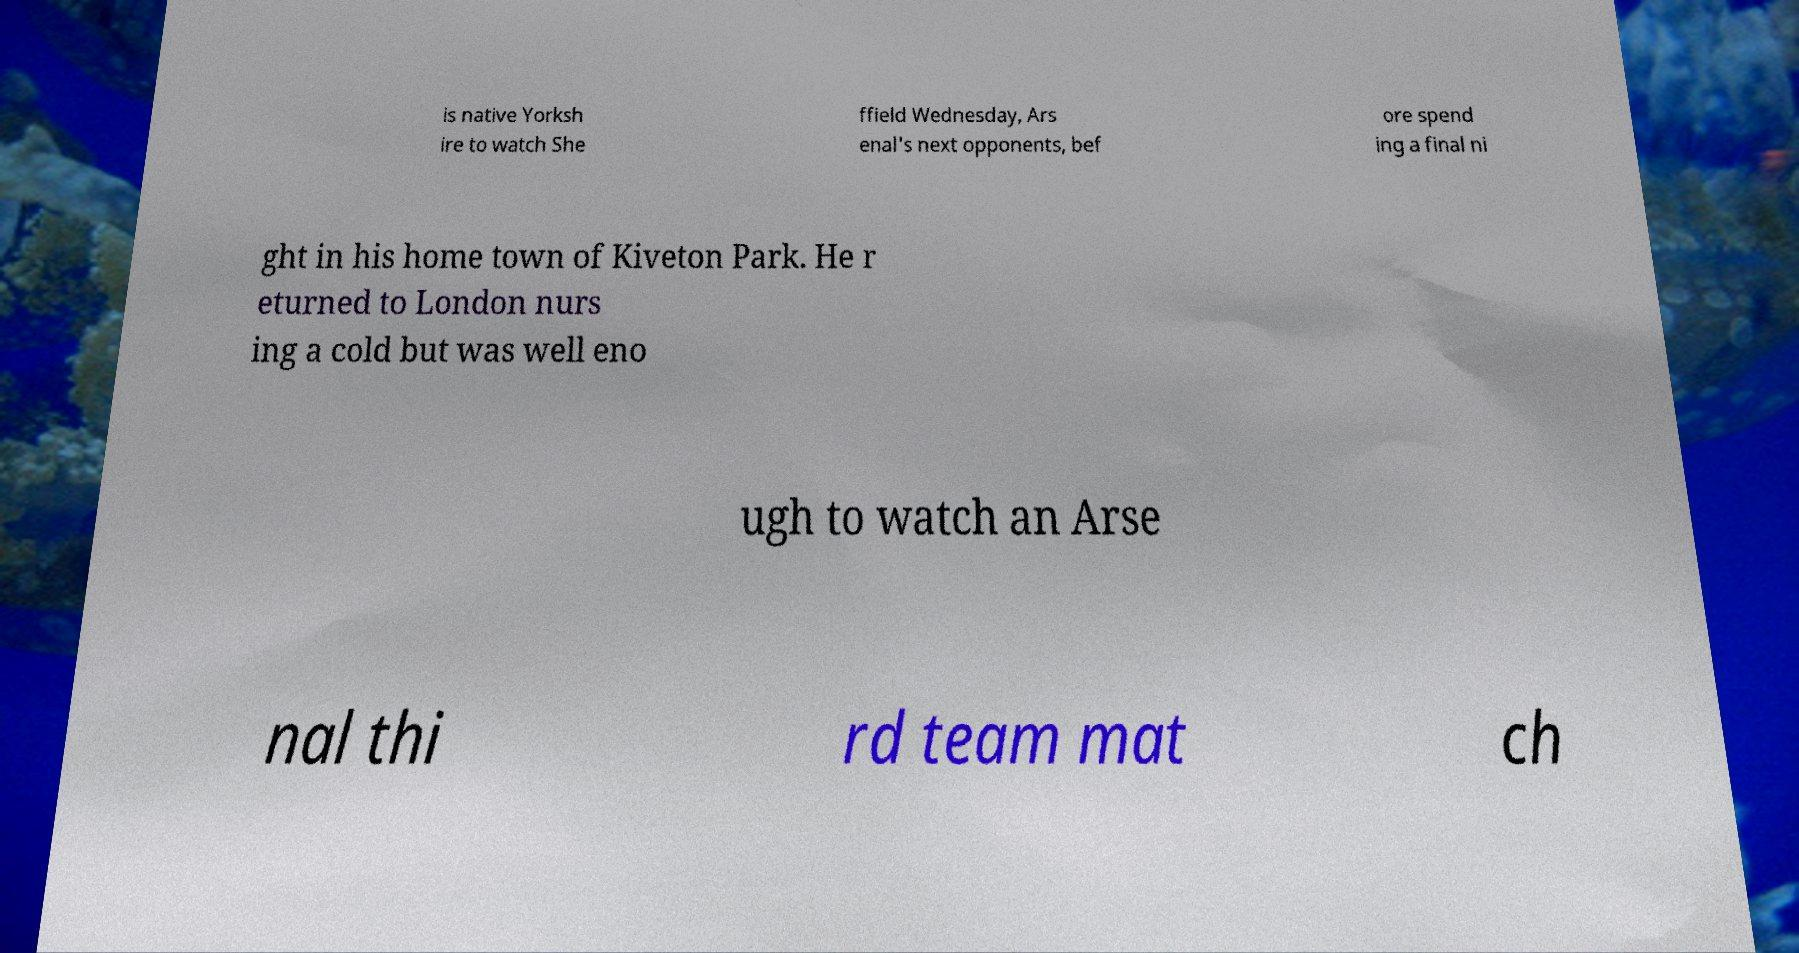Please read and relay the text visible in this image. What does it say? is native Yorksh ire to watch She ffield Wednesday, Ars enal's next opponents, bef ore spend ing a final ni ght in his home town of Kiveton Park. He r eturned to London nurs ing a cold but was well eno ugh to watch an Arse nal thi rd team mat ch 